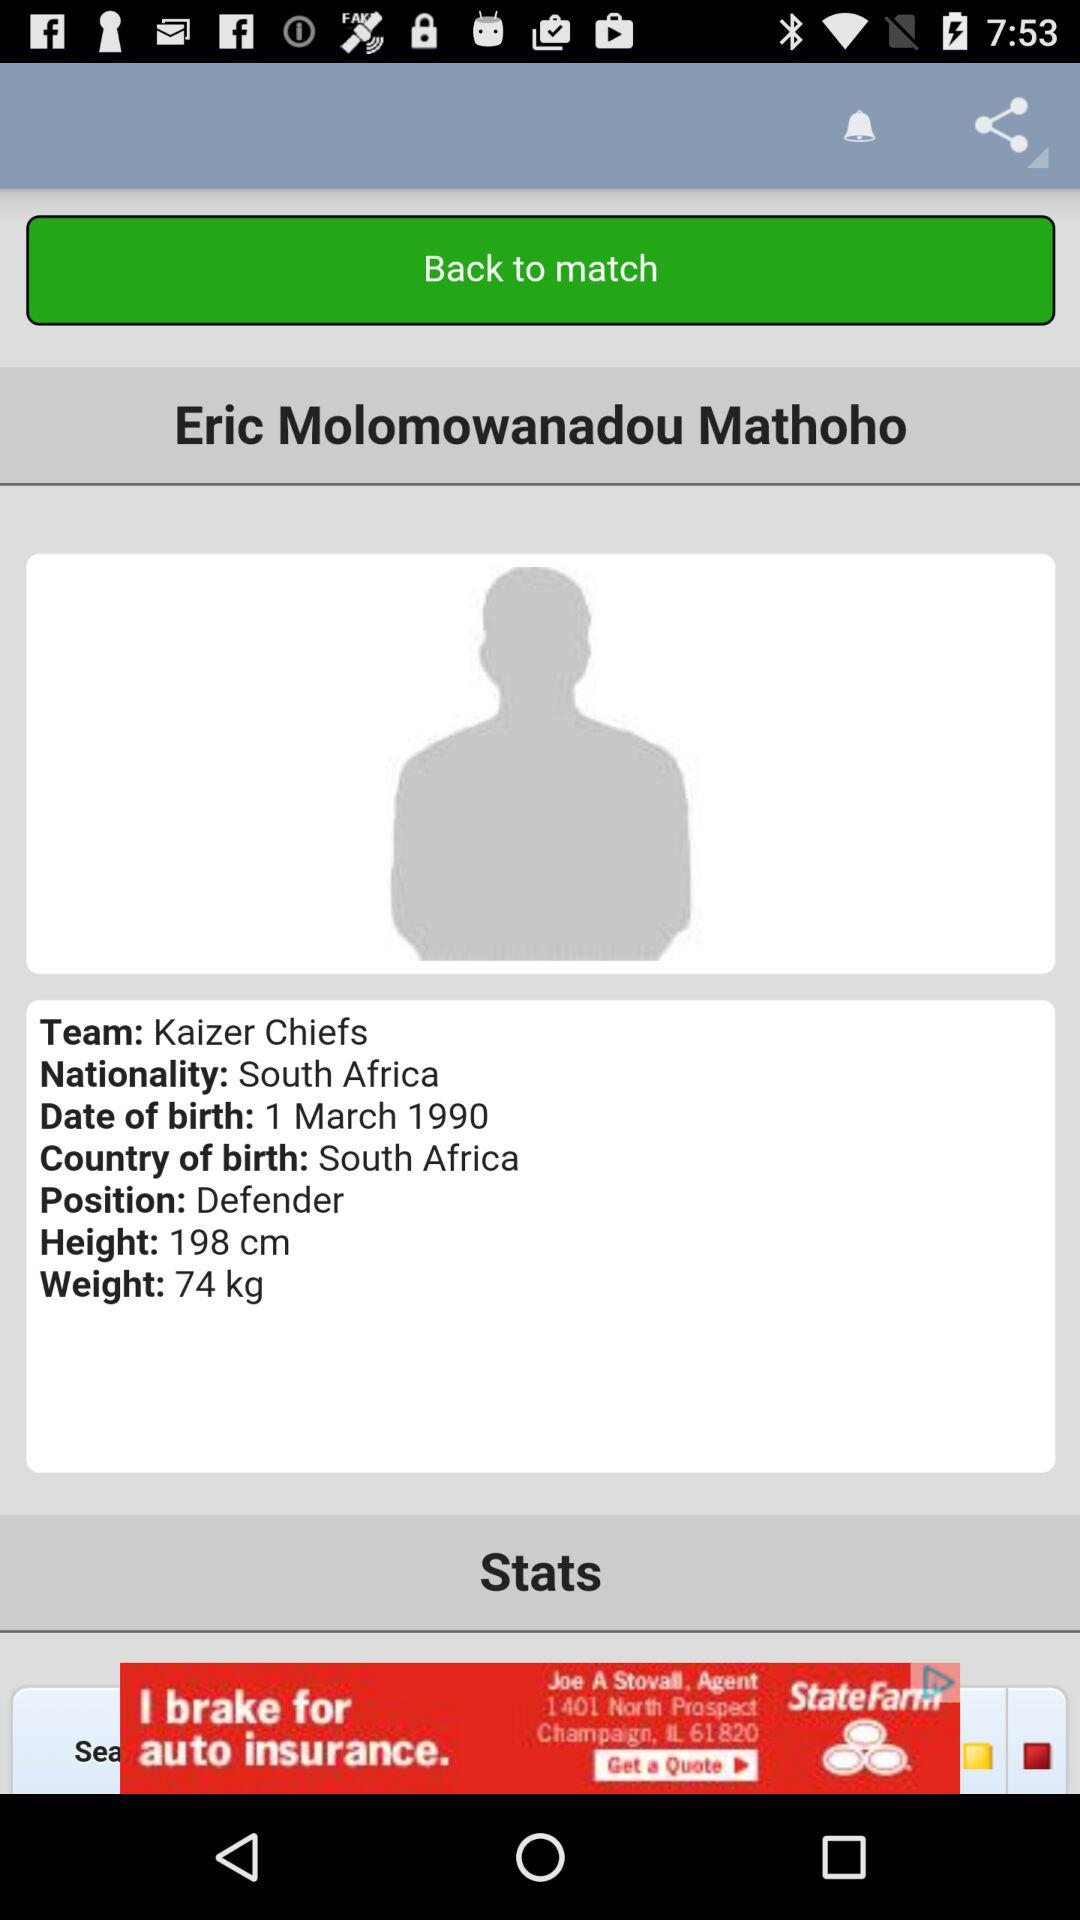What is the country of birth? The country of birth is South Africa. 